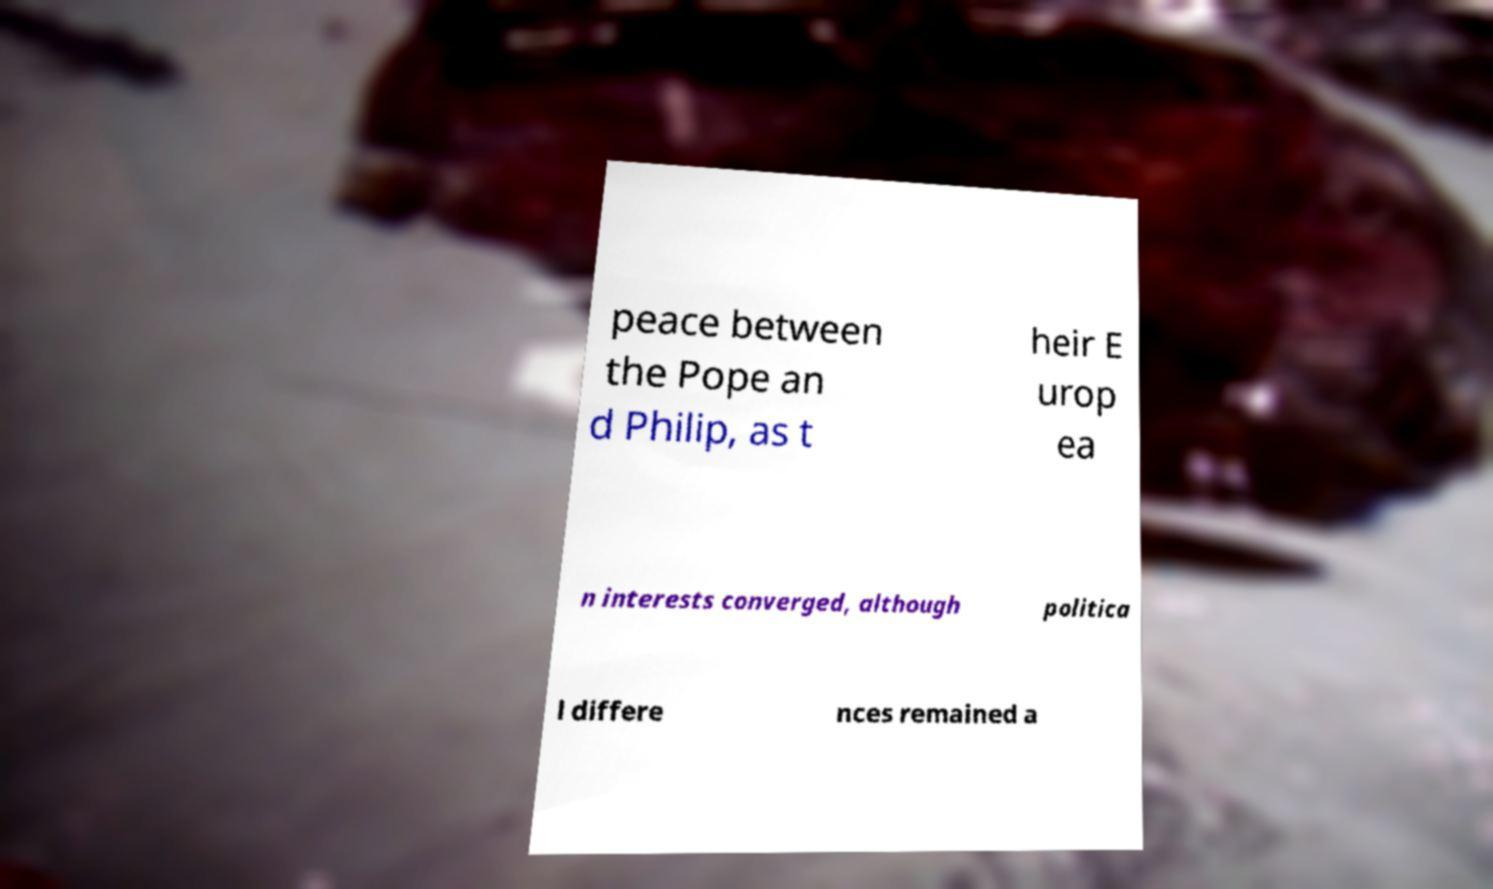What messages or text are displayed in this image? I need them in a readable, typed format. peace between the Pope an d Philip, as t heir E urop ea n interests converged, although politica l differe nces remained a 